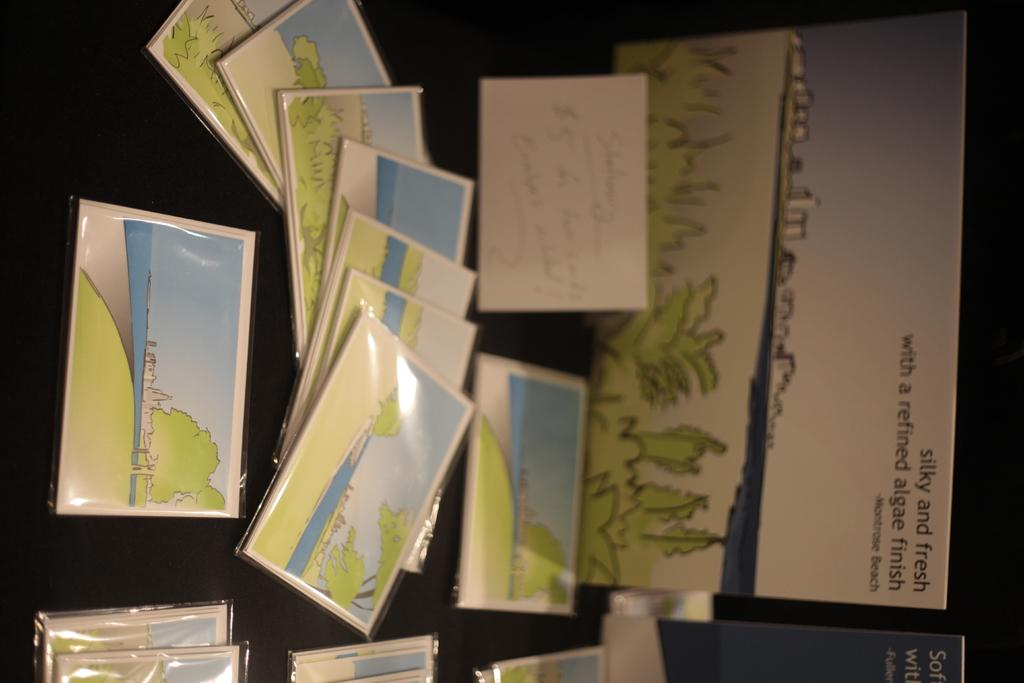Provide a one-sentence caption for the provided image. Montrose Beach is know as being silly and fresh with a refined algae finish. 